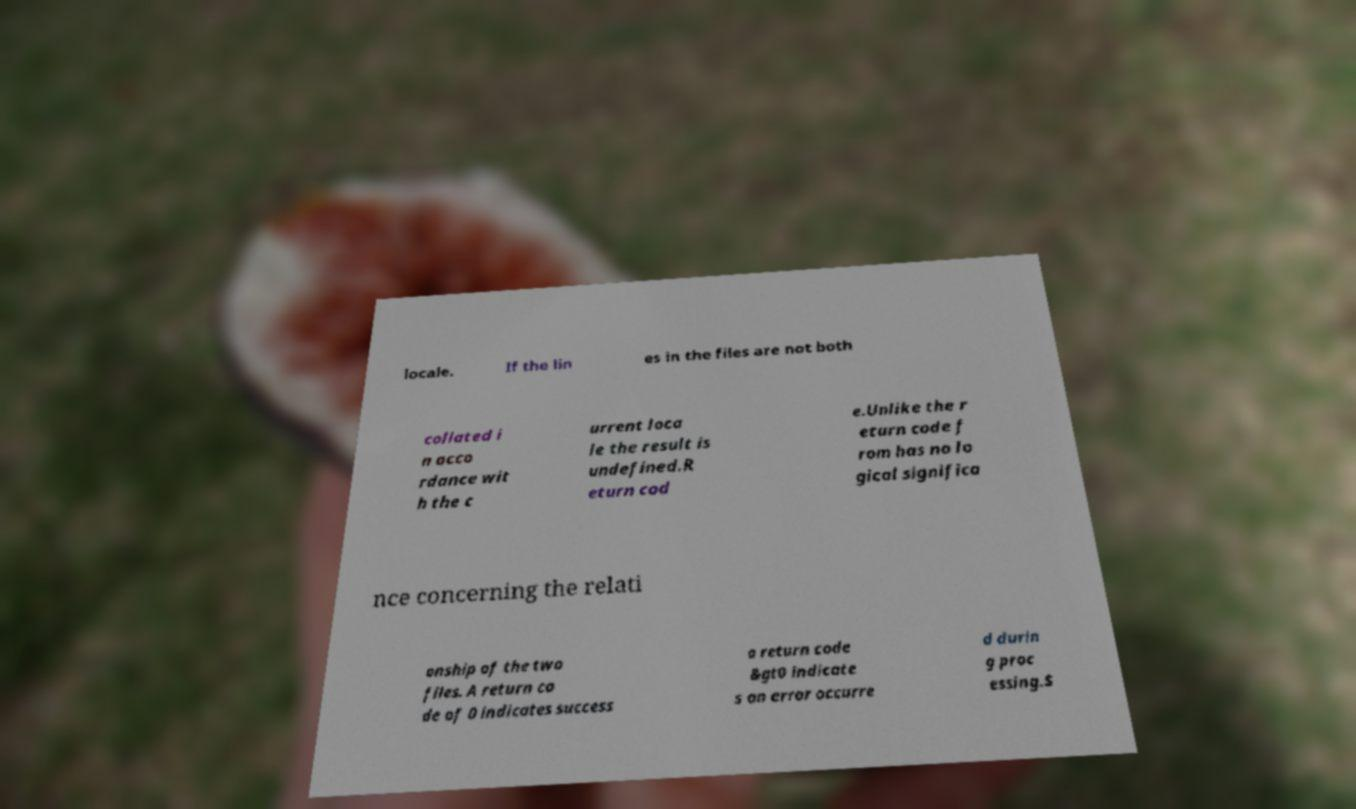For documentation purposes, I need the text within this image transcribed. Could you provide that? locale. If the lin es in the files are not both collated i n acco rdance wit h the c urrent loca le the result is undefined.R eturn cod e.Unlike the r eturn code f rom has no lo gical significa nce concerning the relati onship of the two files. A return co de of 0 indicates success a return code &gt0 indicate s an error occurre d durin g proc essing.$ 